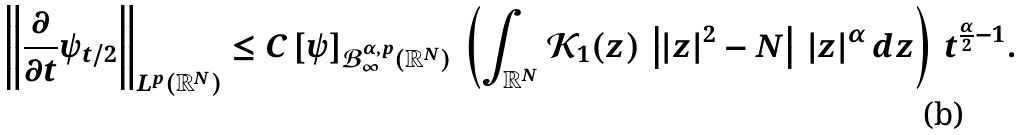Convert formula to latex. <formula><loc_0><loc_0><loc_500><loc_500>\left \| \frac { \partial } { \partial t } \psi _ { t / 2 } \right \| _ { L ^ { p } ( \mathbb { R } ^ { N } ) } & \leq C \, [ \psi ] _ { \mathcal { B } ^ { \alpha , p } _ { \infty } ( \mathbb { R } ^ { N } ) } \, \left ( \int _ { \mathbb { R } ^ { N } } \mathcal { K } _ { 1 } ( z ) \, \left | | z | ^ { 2 } - N \right | \, | z | ^ { \alpha } \, d z \right ) \, t ^ { \frac { \alpha } { 2 } - 1 } .</formula> 